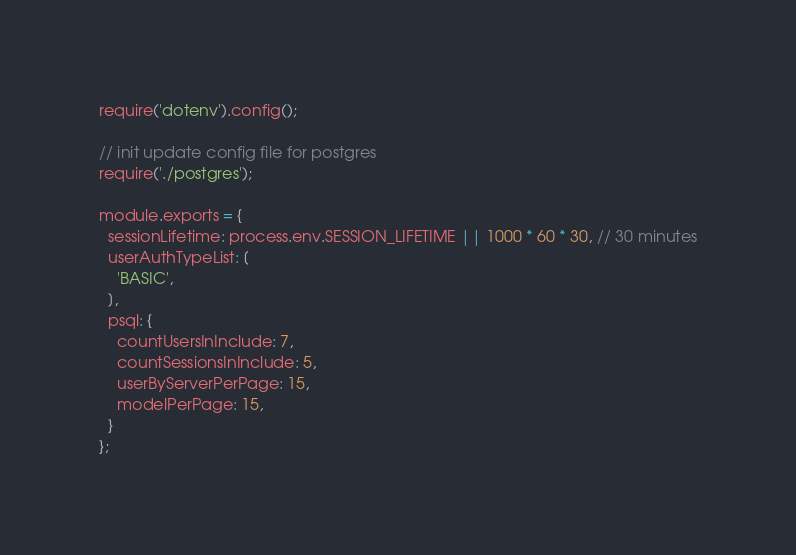Convert code to text. <code><loc_0><loc_0><loc_500><loc_500><_JavaScript_>require('dotenv').config();

// init update config file for postgres
require('./postgres');

module.exports = {
  sessionLifetime: process.env.SESSION_LIFETIME || 1000 * 60 * 30, // 30 minutes
  userAuthTypeList: [
    'BASIC',
  ],
  psql: {
    countUsersInInclude: 7,
    countSessionsInInclude: 5,
    userByServerPerPage: 15,
    modelPerPage: 15,
  }
};
</code> 